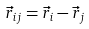<formula> <loc_0><loc_0><loc_500><loc_500>\vec { r } _ { i j } = \vec { r } _ { i } - \vec { r } _ { j }</formula> 